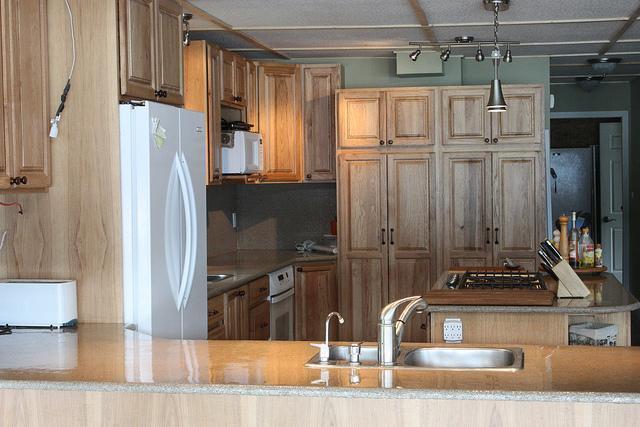Why are there wires sticking out of the wall?
Indicate the correct response by choosing from the four available options to answer the question.
Options: Inspection, decoration, demolition, new construction. New construction. 